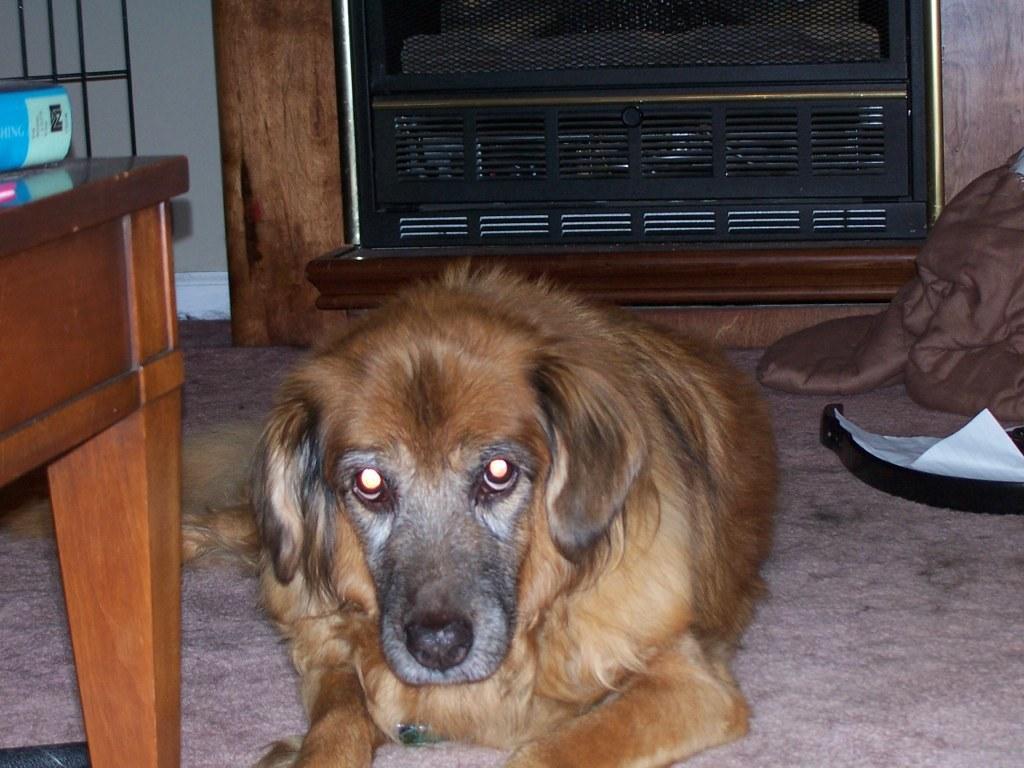Could you give a brief overview of what you see in this image? In this picture we can see a dog in brown colour sitting on a floor. We can see a blanket here. This is a table at the left side of the picture. This is a wall. 